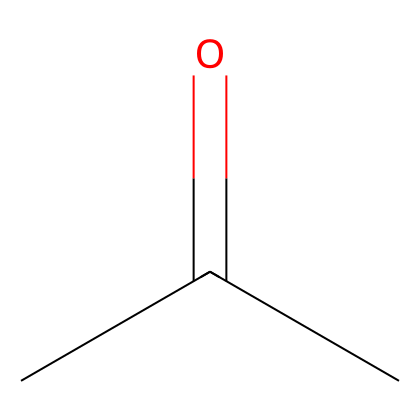What is the molecular formula of this compound? The SMILES representation CC(=O)C indicates the presence of 3 carbon (C) atoms and 6 hydrogen (H) atoms along with 1 oxygen (O) atom. This can be derived from the structural breakdown of the formula and counting each atom present.
Answer: C3H6O How many carbon atoms are in acetone? By examining the SMILES CC(=O)C, we can count the number of carbon atoms directly represented, which are 3 in total.
Answer: 3 What kind of functional group does acetone contain? The presence of the carbonyl group (C=O) in CC(=O)C indicates that acetone has a ketone functional group. The structure shows a carbonyl attached to two other carbon atoms.
Answer: ketone What is the primary use of acetone? Acetone is widely recognized as a solvent, particularly noted for its role in nail polish remover. This information is widely known and can be inferred from common knowledge about the compound.
Answer: solvent Does acetone exhibit hydrogen bonding capabilities? Acetone has polar bonds due to the presence of the carbonyl (C=O), which allows for hydrogen bonding with other polar substances despite not having hydrogen directly attached to oxygen or nitrogen. This is a physical property as suggested by its chemical structure.
Answer: yes What is the significance of the carbonyl group in acetone? The carbonyl group (C=O) is crucial as it defines acetone as a ketone and plays a vital role in its chemical reactivity and solubility properties. The ketone structure facilitates various reactions that are characteristic of ketones.
Answer: defines reactivity 